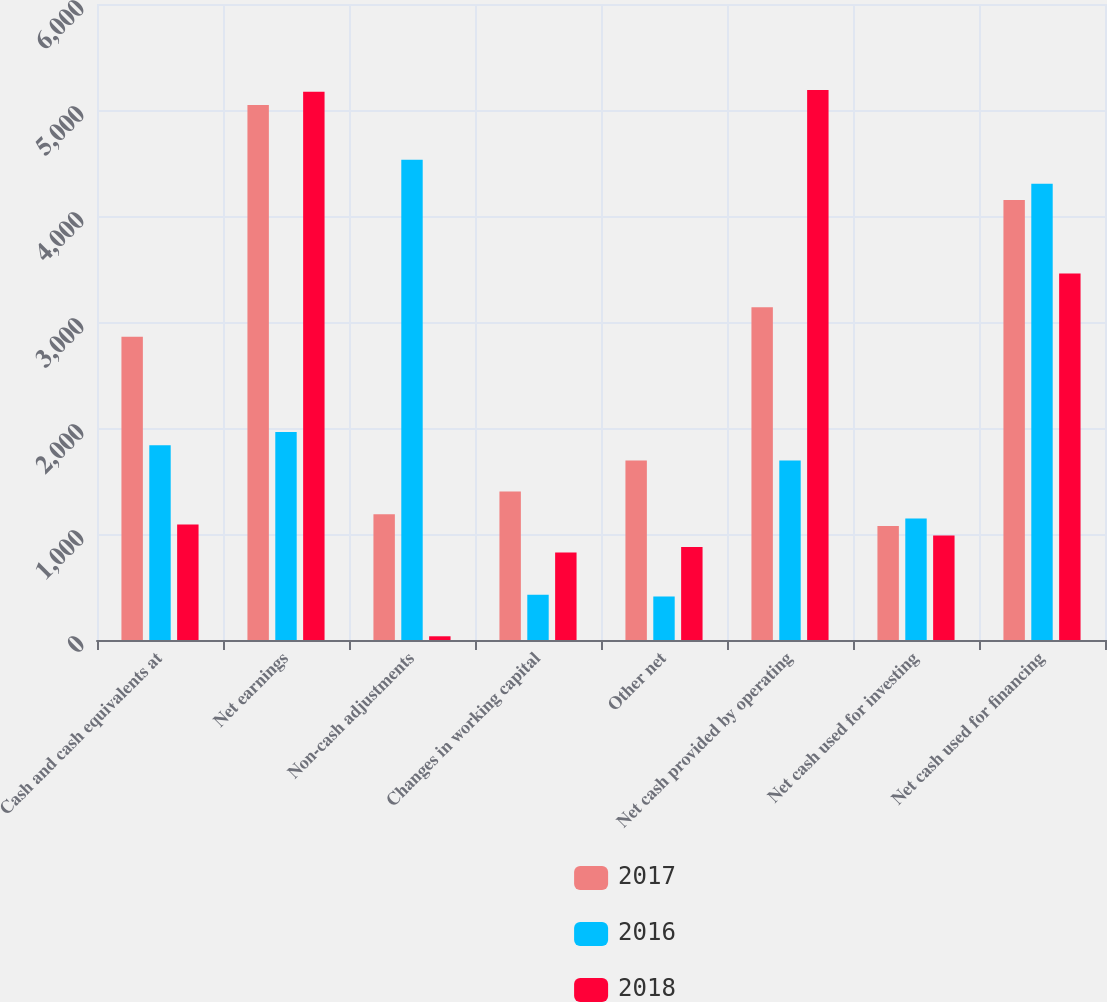Convert chart to OTSL. <chart><loc_0><loc_0><loc_500><loc_500><stacked_bar_chart><ecel><fcel>Cash and cash equivalents at<fcel>Net earnings<fcel>Non-cash adjustments<fcel>Changes in working capital<fcel>Other net<fcel>Net cash provided by operating<fcel>Net cash used for investing<fcel>Net cash used for financing<nl><fcel>2017<fcel>2861<fcel>5046<fcel>1186<fcel>1401<fcel>1693<fcel>3138<fcel>1075<fcel>4152<nl><fcel>2016<fcel>1837<fcel>1963<fcel>4530<fcel>427<fcel>410<fcel>1693<fcel>1147<fcel>4305<nl><fcel>2018<fcel>1090<fcel>5173<fcel>35<fcel>826<fcel>877<fcel>5189<fcel>985<fcel>3457<nl></chart> 